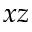Convert formula to latex. <formula><loc_0><loc_0><loc_500><loc_500>x z</formula> 